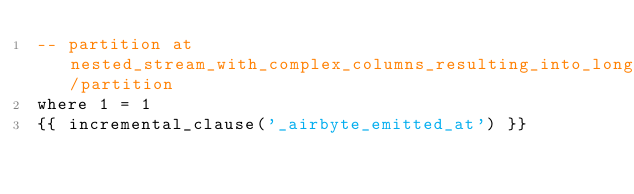Convert code to text. <code><loc_0><loc_0><loc_500><loc_500><_SQL_>-- partition at nested_stream_with_complex_columns_resulting_into_long_names/partition
where 1 = 1
{{ incremental_clause('_airbyte_emitted_at') }}

</code> 